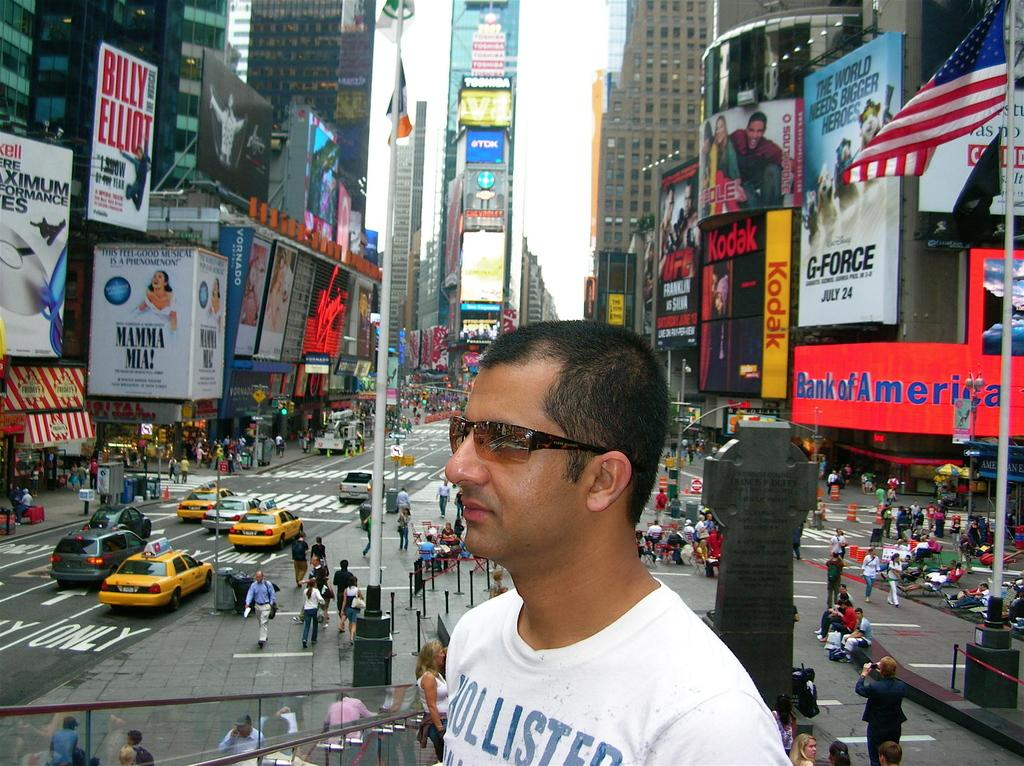<image>
Describe the image concisely. The shown Billy Elliot is being advertised on a poster to the left. 